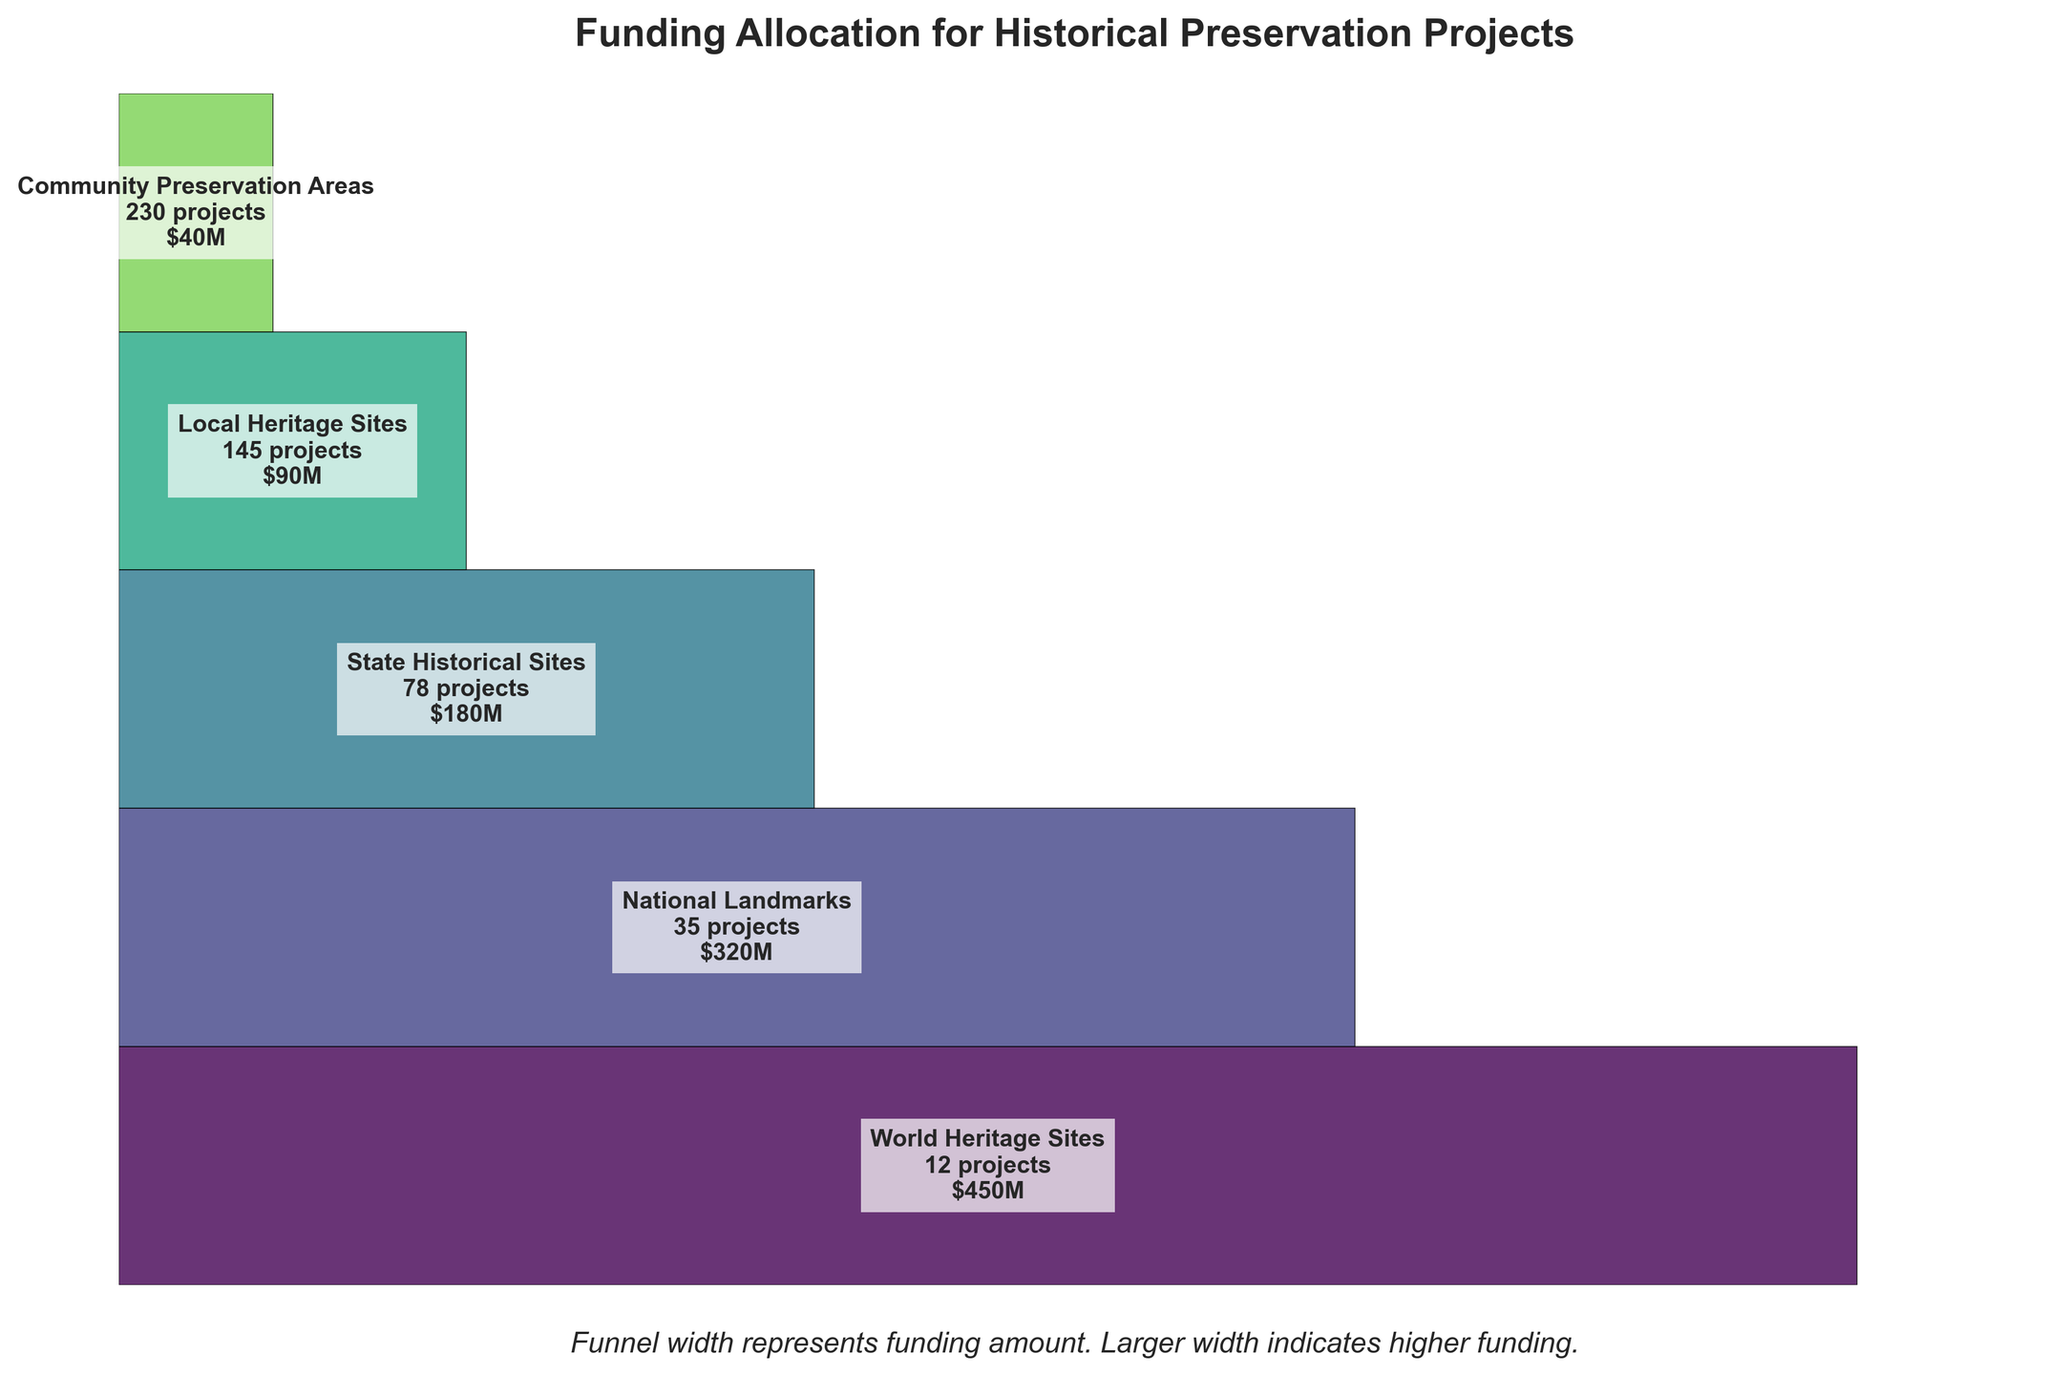How many World Heritage Sites projects are there? The visual shows that World Heritage Sites have a label indicating the number of projects. By looking at this label, we can find the number of projects.
Answer: 12 Which significance level has the maximum total funding? By comparing the width of each funnel section, the section with the maximum width corresponds to the one with the highest funding. World Heritage Sites have the widest section.
Answer: World Heritage Sites What is the total funding for State Historical Sites and Local Heritage Sites combined? The total funding amounts for State Historical Sites and Local Heritage Sites are $180 million and $90 million respectively. Adding these gives $180M + $90M = $270M.
Answer: $270M Which significance level has the least number of projects, and how many does it have? By examining the labels on the funnel chart, we can see the number of projects for each significance level. The level with the smallest number is World Heritage Sites.
Answer: World Heritage Sites, 12 Comparing National Landmarks and Community Preservation Areas, which one has more funding and by how much? National Landmarks have $320M in funding, while Community Preservation Areas have $40M. The difference is $320M - $40M = $280M.
Answer: National Landmarks, $280M Which significance level has a relatively high number of projects but receives less funding? By examining the funnel chart and comparing the number of projects and funding amounts, Local Heritage Sites have 145 projects but receive only $90M, which is less relative to their number of projects.
Answer: Local Heritage Sites How does the funding for National Landmarks compare to State Historical Sites? By checking the width of the funnel sections, National Landmarks have $320M, and State Historical Sites have $180M. National Landmarks receive more funding.
Answer: National Landmarks receive more What do the colors in the funnel chart represent? Different colors represent different significance levels of the projects. This helps to visually differentiate each segment of the funnel.
Answer: Significance levels If we add the number of projects for Community Preservation Areas and Local Heritage Sites, what do we get? Community Preservation Areas have 230 projects and Local Heritage Sites have 145. Summing these gives 230 + 145 = 375 projects.
Answer: 375 What is the significance of the width of each segment in the funnel chart? The width of each segment represents the total funding amount for that significance level. A larger width indicates a higher amount of funding allocated.
Answer: Represents funding amount 